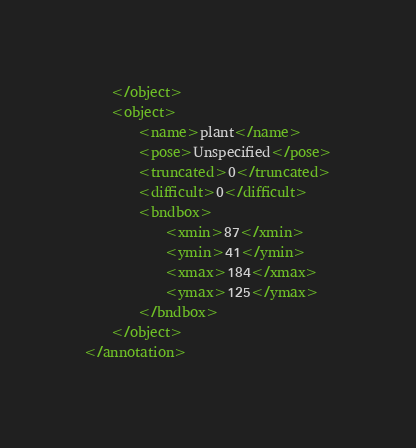<code> <loc_0><loc_0><loc_500><loc_500><_XML_>	</object>
	<object>
		<name>plant</name>
		<pose>Unspecified</pose>
		<truncated>0</truncated>
		<difficult>0</difficult>
		<bndbox>
			<xmin>87</xmin>
			<ymin>41</ymin>
			<xmax>184</xmax>
			<ymax>125</ymax>
		</bndbox>
	</object>
</annotation>
</code> 